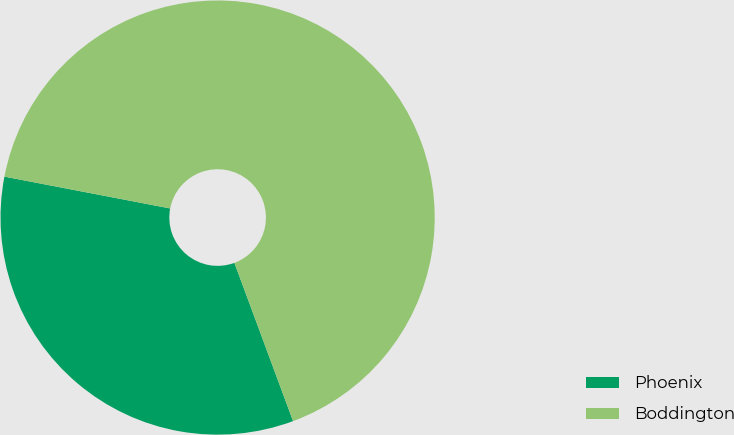Convert chart. <chart><loc_0><loc_0><loc_500><loc_500><pie_chart><fcel>Phoenix<fcel>Boddington<nl><fcel>33.67%<fcel>66.33%<nl></chart> 